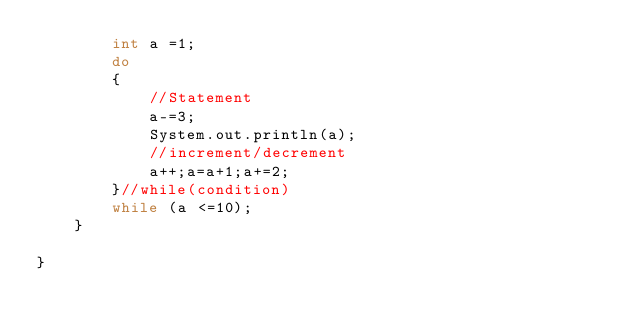<code> <loc_0><loc_0><loc_500><loc_500><_Java_>		int a =1;
		do 
		{
			//Statement
			a-=3;
			System.out.println(a);
			//increment/decrement
			a++;a=a+1;a+=2;
		}//while(condition)
		while (a <=10);
	}

}
</code> 